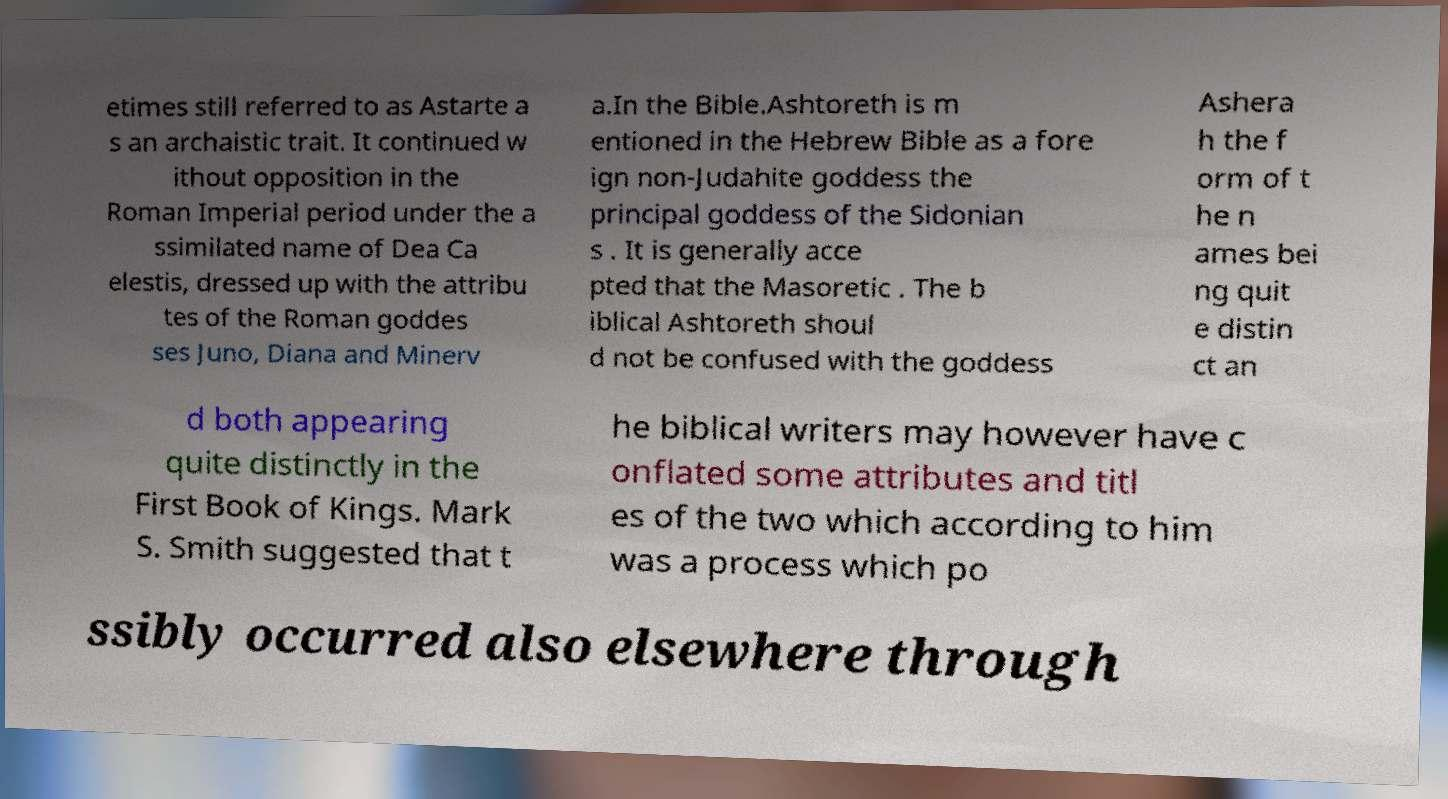Could you assist in decoding the text presented in this image and type it out clearly? etimes still referred to as Astarte a s an archaistic trait. It continued w ithout opposition in the Roman Imperial period under the a ssimilated name of Dea Ca elestis, dressed up with the attribu tes of the Roman goddes ses Juno, Diana and Minerv a.In the Bible.Ashtoreth is m entioned in the Hebrew Bible as a fore ign non-Judahite goddess the principal goddess of the Sidonian s . It is generally acce pted that the Masoretic . The b iblical Ashtoreth shoul d not be confused with the goddess Ashera h the f orm of t he n ames bei ng quit e distin ct an d both appearing quite distinctly in the First Book of Kings. Mark S. Smith suggested that t he biblical writers may however have c onflated some attributes and titl es of the two which according to him was a process which po ssibly occurred also elsewhere through 